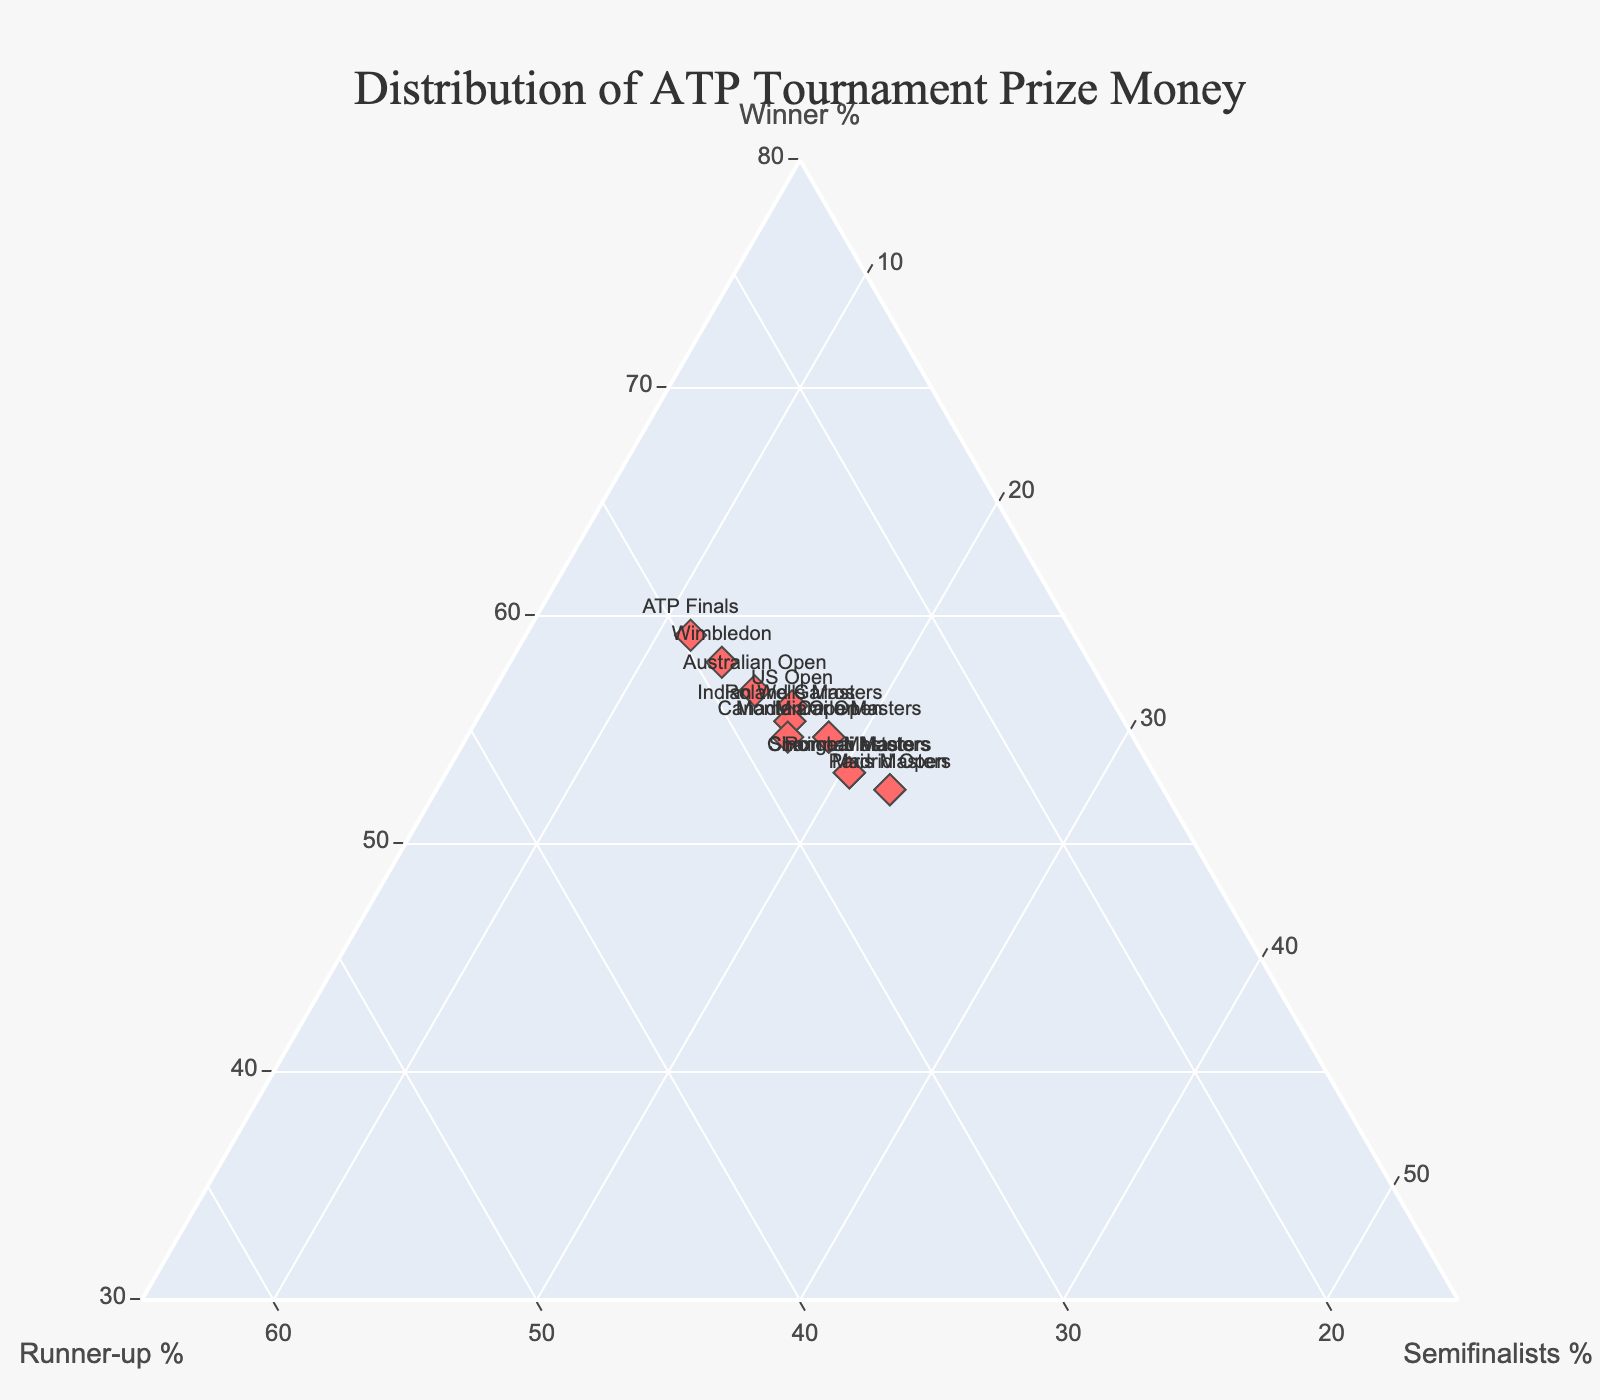How many tournaments are displayed on the plot? By reviewing the figure, you can visually count the number of data points (markers) representing tournaments.
Answer: 14 Which tournament allocates the highest percentage of prize money to the winner? Look for the marker closest to the 'Winner %' axis maximum, and hover over it to confirm the exact tournament.
Answer: ATP Finals What is the title of the figure? You can find this information at the top center of the figure.
Answer: Distribution of ATP Tournament Prize Money Which tournament provides the lowest percentage of prize money to the semifinalists? Identify the marker closest to the 'Semifinalists %' axis minimum, and hover over it to find the tournament.
Answer: ATP Finals Compare the percentage of prize money allocation to the runner-up in the Indian Wells Masters and the Wimbledon tournaments. Which tournament allocates more to the runner-up? By hovering over the markers for both tournaments, compare the 'Runner-up %' for each.
Answer: Wimbledon Which tournament has an equal percentage of prize money allocation to the runner-up and semifinalists? Check if there is any marker where the values of 'Runner-up %' and 'Semifinalists %' are the same.
Answer: None What is the average percentage allocation to winners among the four Grand Slam tournaments? Identify the 'Winner %' for Australian Open, Roland Garros, Wimbledon, and US Open, then calculate the average: (38+36+40+37)/4.
Answer: 37.75% What's the difference in the percentage of prize money allocation to the runner-up between the US Open and the Canadian Open? Subtract the 'Runner-up %' of each tournament: 18% (US Open) - 18% (Canadian Open).
Answer: 0% What is the combined percentage of prize money allocated to winners and runners-up at the Madrid Open? Add the 'Winner %' and 'Runner-up %' for the Madrid Open: 33% + 16%.
Answer: 49% How does the Miami Open's prize distribution compare to the Rome Masters in terms of semifinalists? By comparing their 'Semifinalists %' values, identify which is higher.
Answer: Rome Masters 